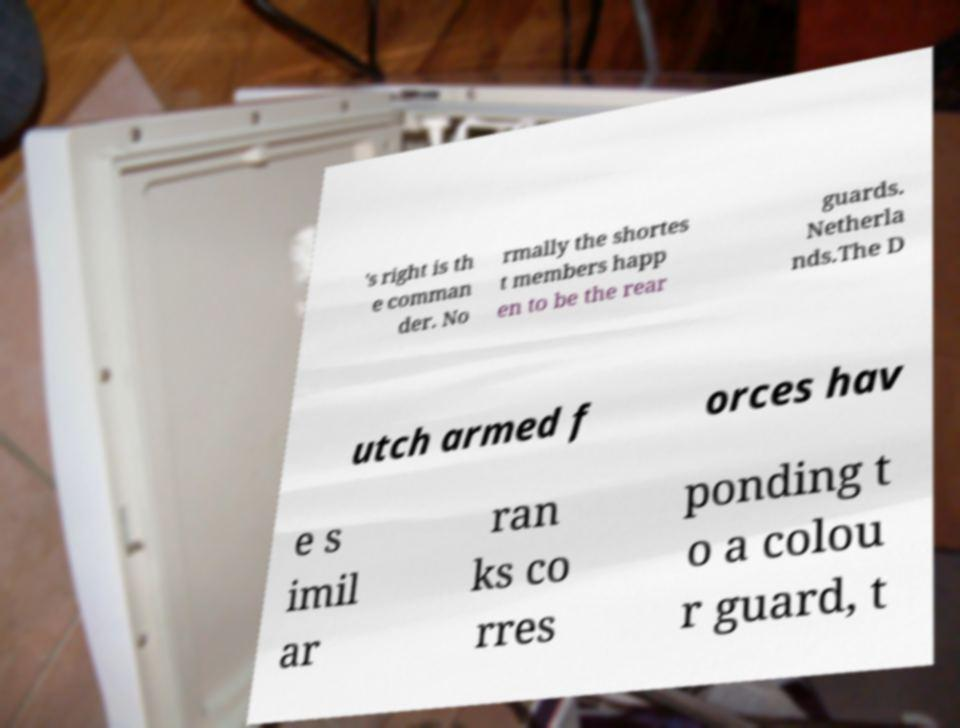Please identify and transcribe the text found in this image. 's right is th e comman der. No rmally the shortes t members happ en to be the rear guards. Netherla nds.The D utch armed f orces hav e s imil ar ran ks co rres ponding t o a colou r guard, t 